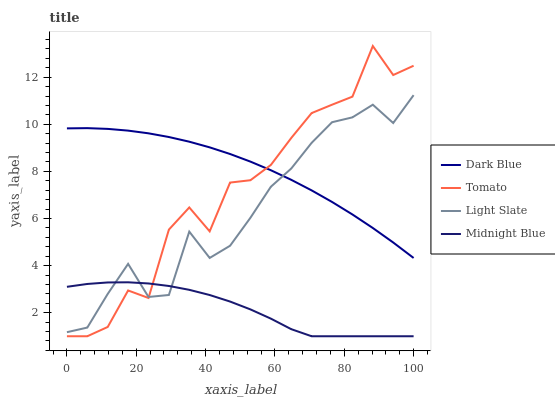Does Midnight Blue have the minimum area under the curve?
Answer yes or no. Yes. Does Dark Blue have the maximum area under the curve?
Answer yes or no. Yes. Does Dark Blue have the minimum area under the curve?
Answer yes or no. No. Does Midnight Blue have the maximum area under the curve?
Answer yes or no. No. Is Dark Blue the smoothest?
Answer yes or no. Yes. Is Tomato the roughest?
Answer yes or no. Yes. Is Midnight Blue the smoothest?
Answer yes or no. No. Is Midnight Blue the roughest?
Answer yes or no. No. Does Tomato have the lowest value?
Answer yes or no. Yes. Does Dark Blue have the lowest value?
Answer yes or no. No. Does Tomato have the highest value?
Answer yes or no. Yes. Does Dark Blue have the highest value?
Answer yes or no. No. Is Midnight Blue less than Dark Blue?
Answer yes or no. Yes. Is Dark Blue greater than Midnight Blue?
Answer yes or no. Yes. Does Midnight Blue intersect Tomato?
Answer yes or no. Yes. Is Midnight Blue less than Tomato?
Answer yes or no. No. Is Midnight Blue greater than Tomato?
Answer yes or no. No. Does Midnight Blue intersect Dark Blue?
Answer yes or no. No. 